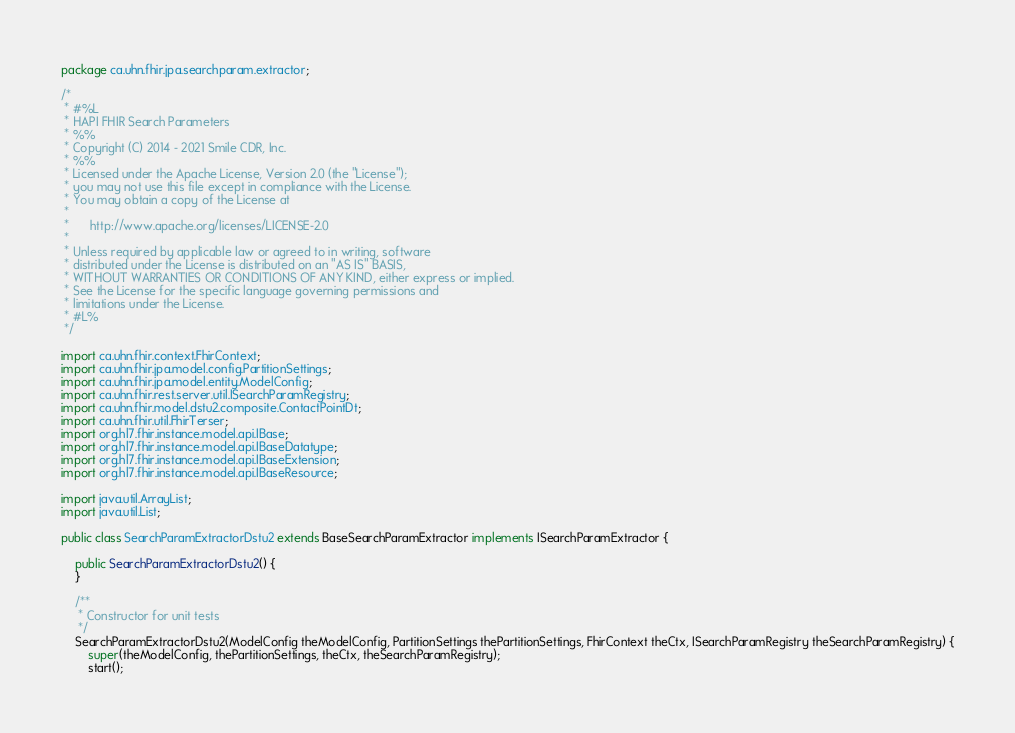<code> <loc_0><loc_0><loc_500><loc_500><_Java_>package ca.uhn.fhir.jpa.searchparam.extractor;

/*
 * #%L
 * HAPI FHIR Search Parameters
 * %%
 * Copyright (C) 2014 - 2021 Smile CDR, Inc.
 * %%
 * Licensed under the Apache License, Version 2.0 (the "License");
 * you may not use this file except in compliance with the License.
 * You may obtain a copy of the License at
 *
 *      http://www.apache.org/licenses/LICENSE-2.0
 *
 * Unless required by applicable law or agreed to in writing, software
 * distributed under the License is distributed on an "AS IS" BASIS,
 * WITHOUT WARRANTIES OR CONDITIONS OF ANY KIND, either express or implied.
 * See the License for the specific language governing permissions and
 * limitations under the License.
 * #L%
 */

import ca.uhn.fhir.context.FhirContext;
import ca.uhn.fhir.jpa.model.config.PartitionSettings;
import ca.uhn.fhir.jpa.model.entity.ModelConfig;
import ca.uhn.fhir.rest.server.util.ISearchParamRegistry;
import ca.uhn.fhir.model.dstu2.composite.ContactPointDt;
import ca.uhn.fhir.util.FhirTerser;
import org.hl7.fhir.instance.model.api.IBase;
import org.hl7.fhir.instance.model.api.IBaseDatatype;
import org.hl7.fhir.instance.model.api.IBaseExtension;
import org.hl7.fhir.instance.model.api.IBaseResource;

import java.util.ArrayList;
import java.util.List;

public class SearchParamExtractorDstu2 extends BaseSearchParamExtractor implements ISearchParamExtractor {

	public SearchParamExtractorDstu2() {
	}

	/**
	 * Constructor for unit tests
	 */
	SearchParamExtractorDstu2(ModelConfig theModelConfig, PartitionSettings thePartitionSettings, FhirContext theCtx, ISearchParamRegistry theSearchParamRegistry) {
		super(theModelConfig, thePartitionSettings, theCtx, theSearchParamRegistry);
		start();</code> 